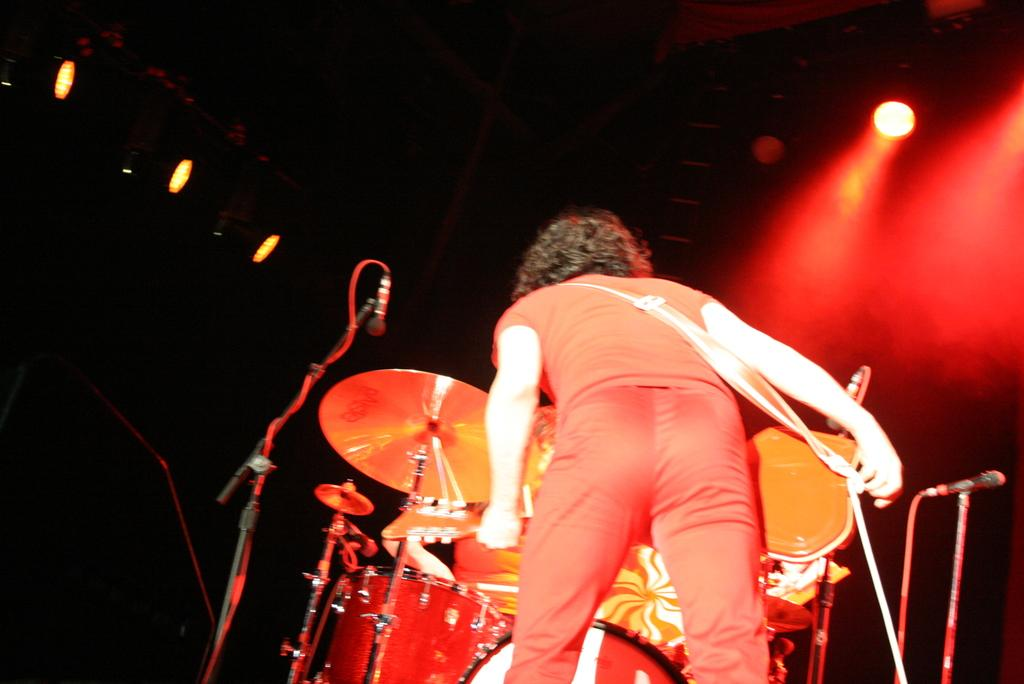Who is in the image? There is a person in the image. What is the person wearing? The person is wearing a red dress. What is the person doing in the image? The person is beating drums. What equipment is present in the image? There are microphones in the image. What can be seen in the background of the image? There are lights in the background of the image. What type of disease is being treated in the image? There is no indication of a disease or treatment in the image; it features a person playing drums. 